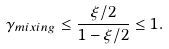<formula> <loc_0><loc_0><loc_500><loc_500>\gamma _ { m i x i n g } \leq \frac { \xi / 2 } { 1 - \xi / 2 } \leq 1 .</formula> 